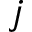Convert formula to latex. <formula><loc_0><loc_0><loc_500><loc_500>j</formula> 